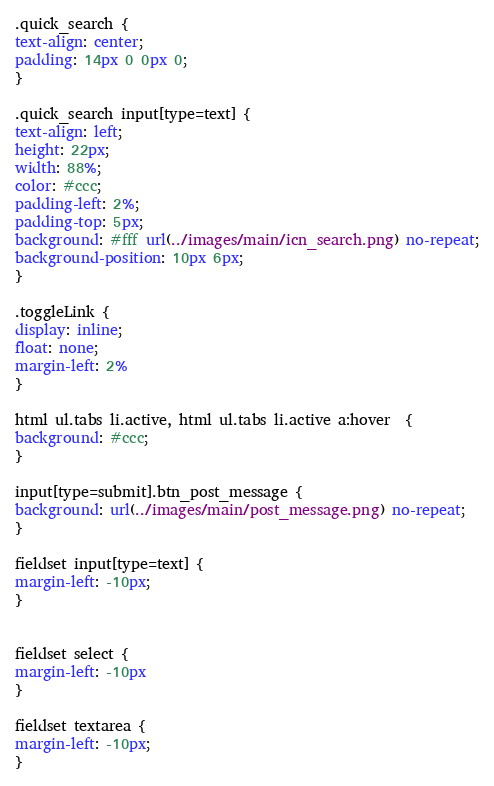<code> <loc_0><loc_0><loc_500><loc_500><_CSS_>.quick_search {
text-align: center;
padding: 14px 0 0px 0;
}

.quick_search input[type=text] {
text-align: left;
height: 22px;
width: 88%;
color: #ccc;
padding-left: 2%;
padding-top: 5px;
background: #fff url(../images/main/icn_search.png) no-repeat;
background-position: 10px 6px;
}

.toggleLink {
display: inline;
float: none;
margin-left: 2%
}

html ul.tabs li.active, html ul.tabs li.active a:hover  {
background: #ccc;
}

input[type=submit].btn_post_message {
background: url(../images/main/post_message.png) no-repeat;
}

fieldset input[type=text] {
margin-left: -10px;
}


fieldset select {
margin-left: -10px
}

fieldset textarea {
margin-left: -10px;
}

</code> 